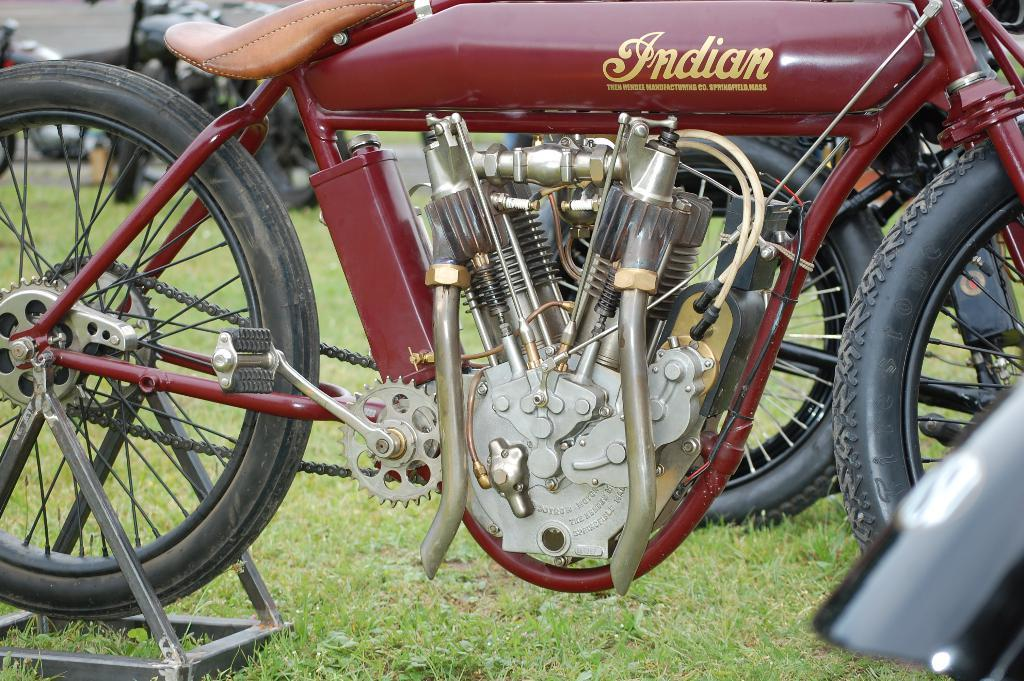What type of vehicle is featured in the image? There is a motorcycle with a name in the image. Are there any other motorcycles visible in the image? Yes, there are other motorcycles on the ground in the image. What type of terrain is present in the image? There is grass on the ground in the image. Where is the zebra located in the image? There is no zebra present in the image. What type of material is the sand made of in the image? There is no sand present in the image. 